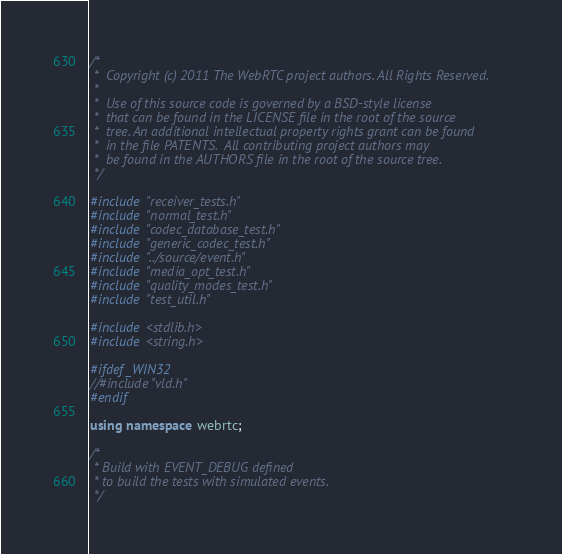<code> <loc_0><loc_0><loc_500><loc_500><_C++_>/*
 *  Copyright (c) 2011 The WebRTC project authors. All Rights Reserved.
 *
 *  Use of this source code is governed by a BSD-style license
 *  that can be found in the LICENSE file in the root of the source
 *  tree. An additional intellectual property rights grant can be found
 *  in the file PATENTS.  All contributing project authors may
 *  be found in the AUTHORS file in the root of the source tree.
 */

#include "receiver_tests.h"
#include "normal_test.h"
#include "codec_database_test.h"
#include "generic_codec_test.h"
#include "../source/event.h"
#include "media_opt_test.h"
#include "quality_modes_test.h"
#include "test_util.h"

#include <stdlib.h>
#include <string.h>

#ifdef _WIN32
//#include "vld.h"
#endif

using namespace webrtc;

/*
 * Build with EVENT_DEBUG defined
 * to build the tests with simulated events.
 */
</code> 